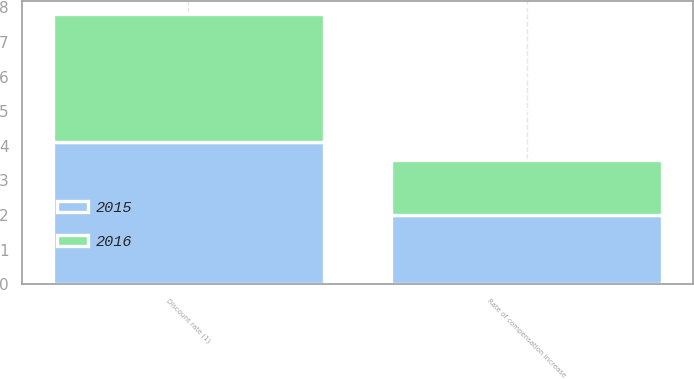Convert chart to OTSL. <chart><loc_0><loc_0><loc_500><loc_500><stacked_bar_chart><ecel><fcel>Discount rate (1)<fcel>Rate of compensation increase<nl><fcel>2016<fcel>3.7<fcel>1.6<nl><fcel>2015<fcel>4.1<fcel>2<nl></chart> 